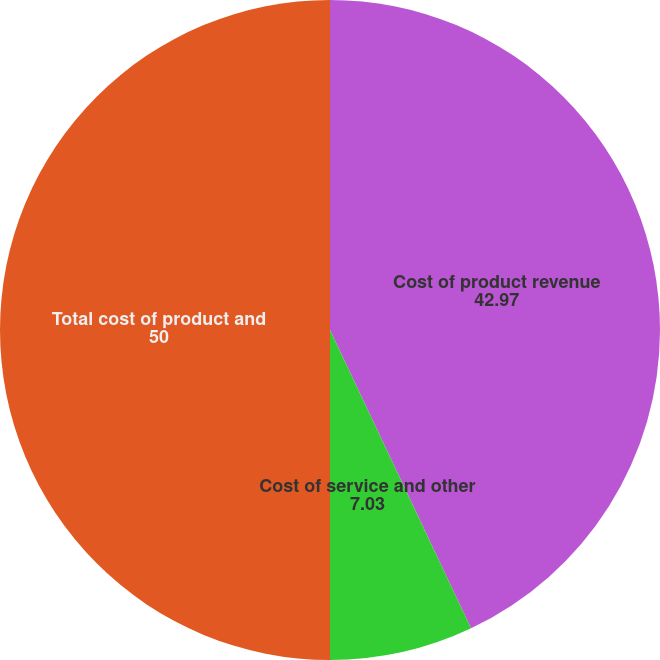Convert chart to OTSL. <chart><loc_0><loc_0><loc_500><loc_500><pie_chart><fcel>Cost of product revenue<fcel>Cost of service and other<fcel>Total cost of product and<nl><fcel>42.97%<fcel>7.03%<fcel>50.0%<nl></chart> 